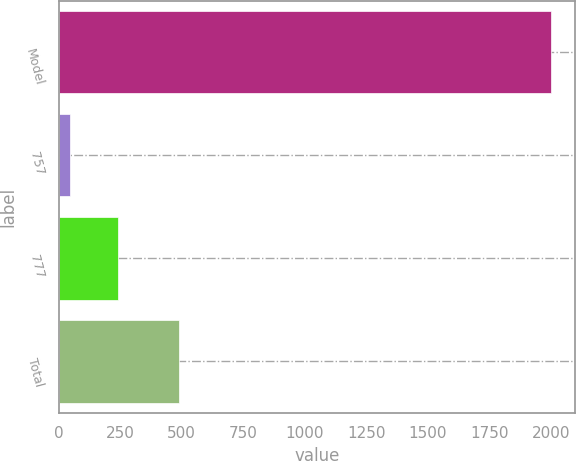<chart> <loc_0><loc_0><loc_500><loc_500><bar_chart><fcel>Model<fcel>757<fcel>777<fcel>Total<nl><fcel>2000<fcel>45<fcel>240.5<fcel>489<nl></chart> 